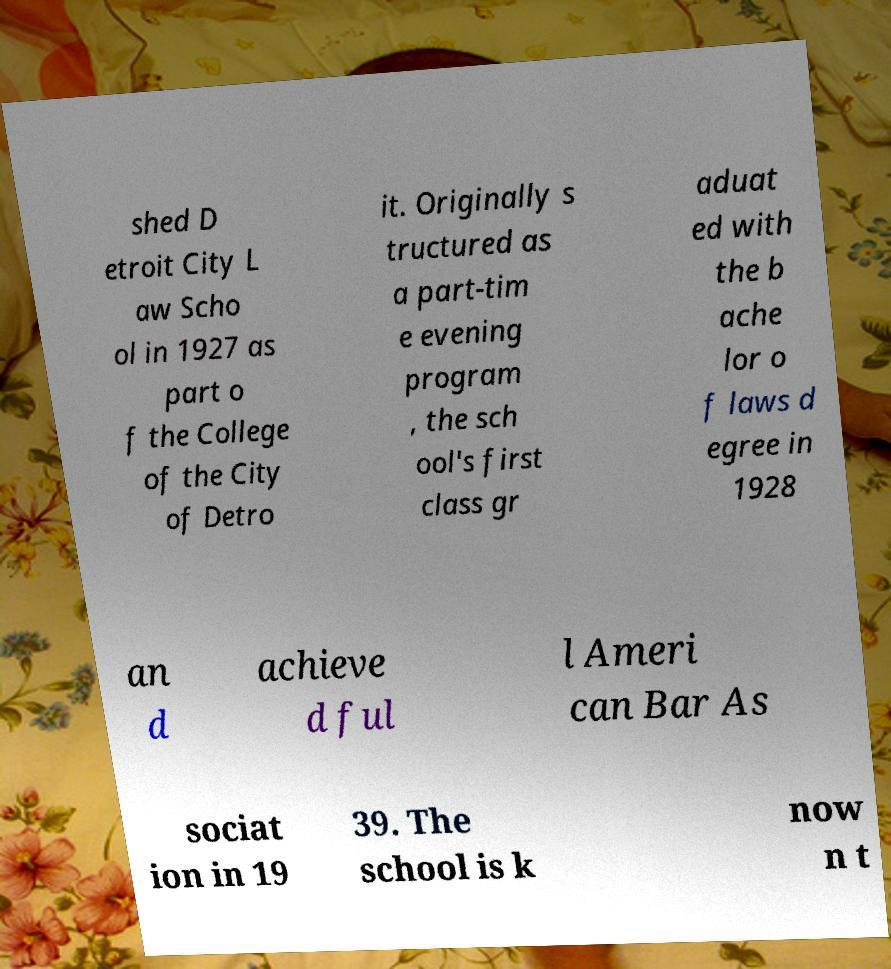Please read and relay the text visible in this image. What does it say? shed D etroit City L aw Scho ol in 1927 as part o f the College of the City of Detro it. Originally s tructured as a part-tim e evening program , the sch ool's first class gr aduat ed with the b ache lor o f laws d egree in 1928 an d achieve d ful l Ameri can Bar As sociat ion in 19 39. The school is k now n t 